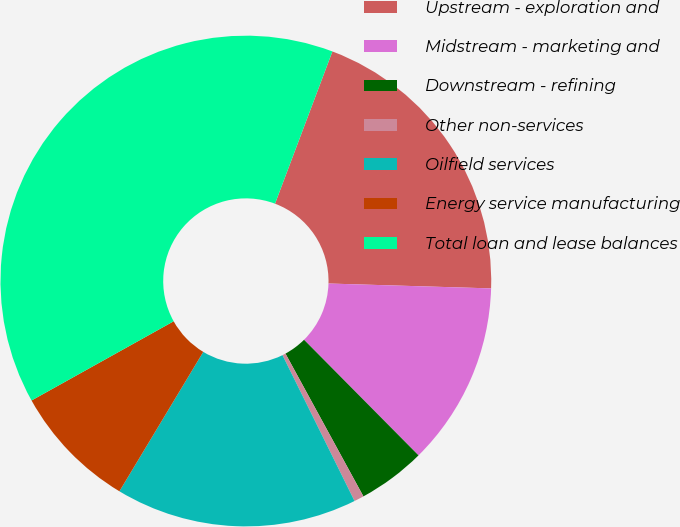Convert chart. <chart><loc_0><loc_0><loc_500><loc_500><pie_chart><fcel>Upstream - exploration and<fcel>Midstream - marketing and<fcel>Downstream - refining<fcel>Other non-services<fcel>Oilfield services<fcel>Energy service manufacturing<fcel>Total loan and lease balances<nl><fcel>19.74%<fcel>12.1%<fcel>4.47%<fcel>0.65%<fcel>15.92%<fcel>8.29%<fcel>38.83%<nl></chart> 